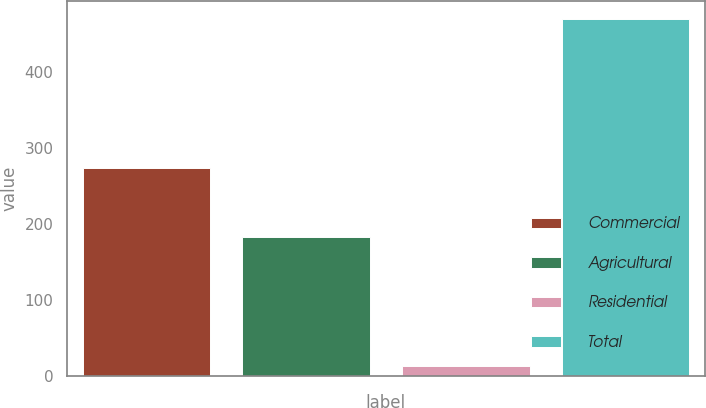Convert chart. <chart><loc_0><loc_0><loc_500><loc_500><bar_chart><fcel>Commercial<fcel>Agricultural<fcel>Residential<fcel>Total<nl><fcel>274<fcel>183<fcel>13<fcel>470<nl></chart> 